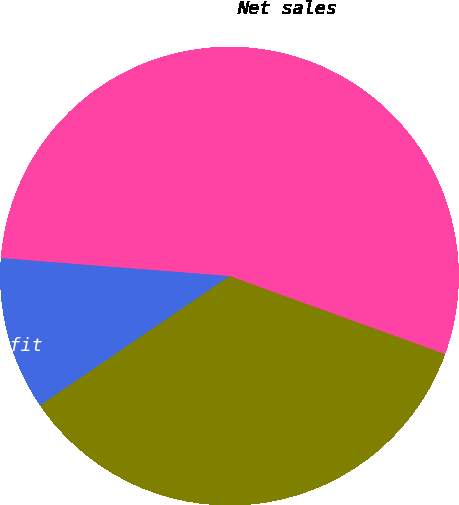<chart> <loc_0><loc_0><loc_500><loc_500><pie_chart><fcel>Net sales<fcel>Net sales to external<fcel>Segment profit<nl><fcel>54.28%<fcel>34.95%<fcel>10.77%<nl></chart> 